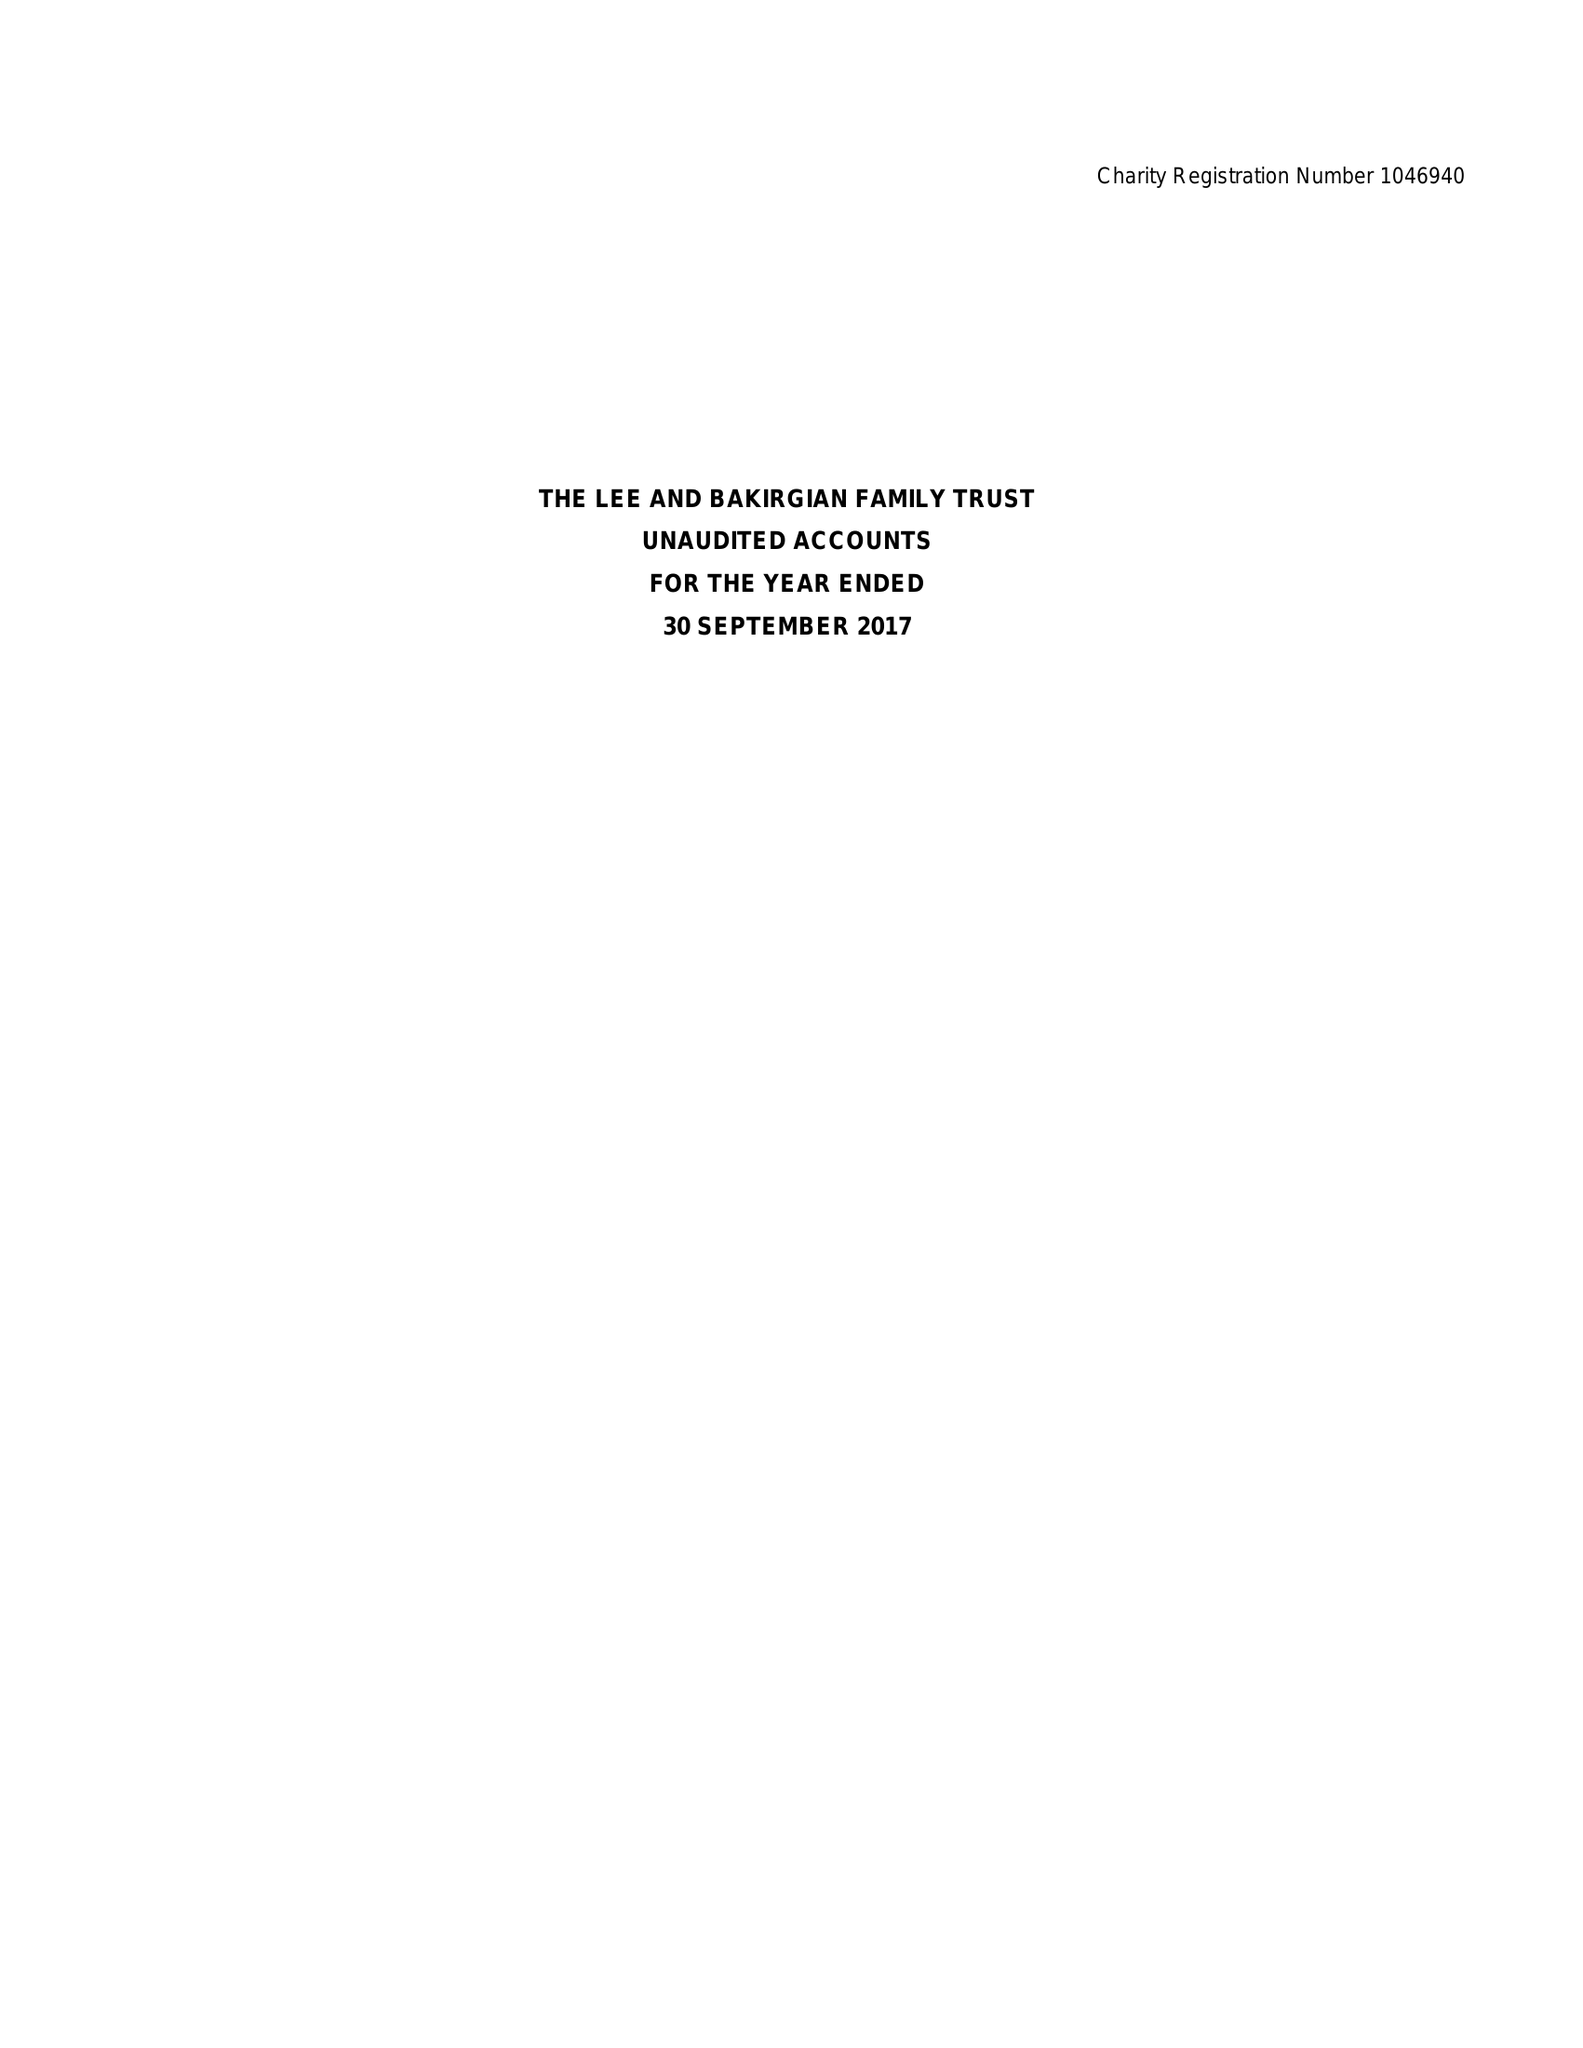What is the value for the charity_name?
Answer the question using a single word or phrase. The Lee and Bakirgian Family Trust 